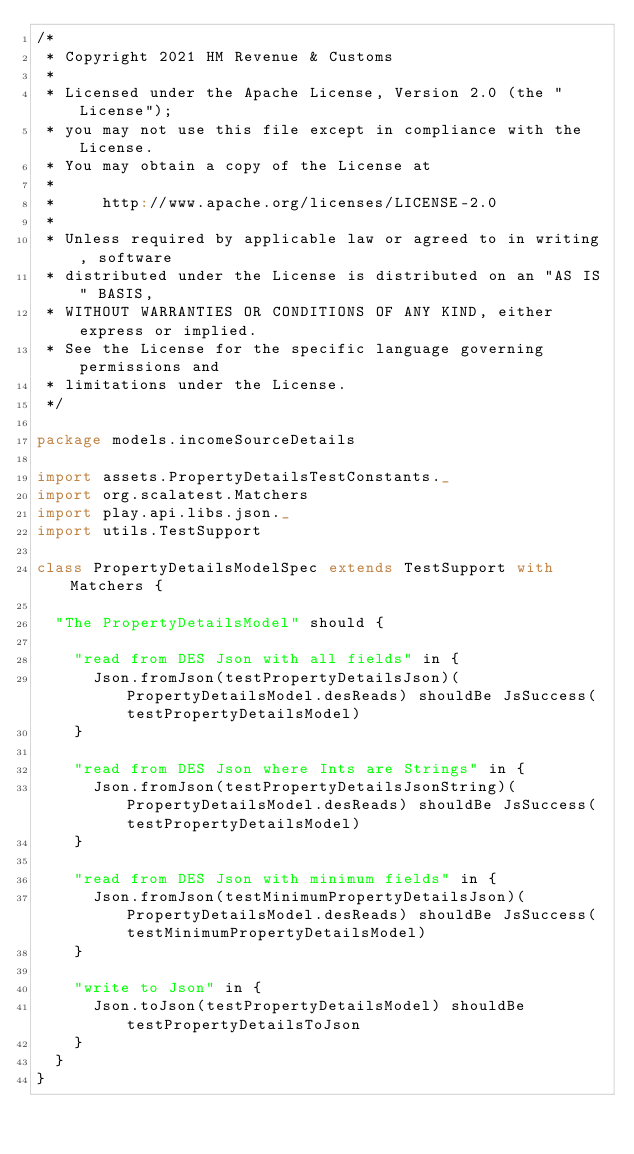<code> <loc_0><loc_0><loc_500><loc_500><_Scala_>/*
 * Copyright 2021 HM Revenue & Customs
 *
 * Licensed under the Apache License, Version 2.0 (the "License");
 * you may not use this file except in compliance with the License.
 * You may obtain a copy of the License at
 *
 *     http://www.apache.org/licenses/LICENSE-2.0
 *
 * Unless required by applicable law or agreed to in writing, software
 * distributed under the License is distributed on an "AS IS" BASIS,
 * WITHOUT WARRANTIES OR CONDITIONS OF ANY KIND, either express or implied.
 * See the License for the specific language governing permissions and
 * limitations under the License.
 */

package models.incomeSourceDetails

import assets.PropertyDetailsTestConstants._
import org.scalatest.Matchers
import play.api.libs.json._
import utils.TestSupport

class PropertyDetailsModelSpec extends TestSupport with Matchers {

  "The PropertyDetailsModel" should {

    "read from DES Json with all fields" in {
      Json.fromJson(testPropertyDetailsJson)(PropertyDetailsModel.desReads) shouldBe JsSuccess(testPropertyDetailsModel)
    }

    "read from DES Json where Ints are Strings" in {
      Json.fromJson(testPropertyDetailsJsonString)(PropertyDetailsModel.desReads) shouldBe JsSuccess(testPropertyDetailsModel)
    }

    "read from DES Json with minimum fields" in {
      Json.fromJson(testMinimumPropertyDetailsJson)(PropertyDetailsModel.desReads) shouldBe JsSuccess(testMinimumPropertyDetailsModel)
    }

    "write to Json" in {
      Json.toJson(testPropertyDetailsModel) shouldBe testPropertyDetailsToJson
    }
  }
}

</code> 